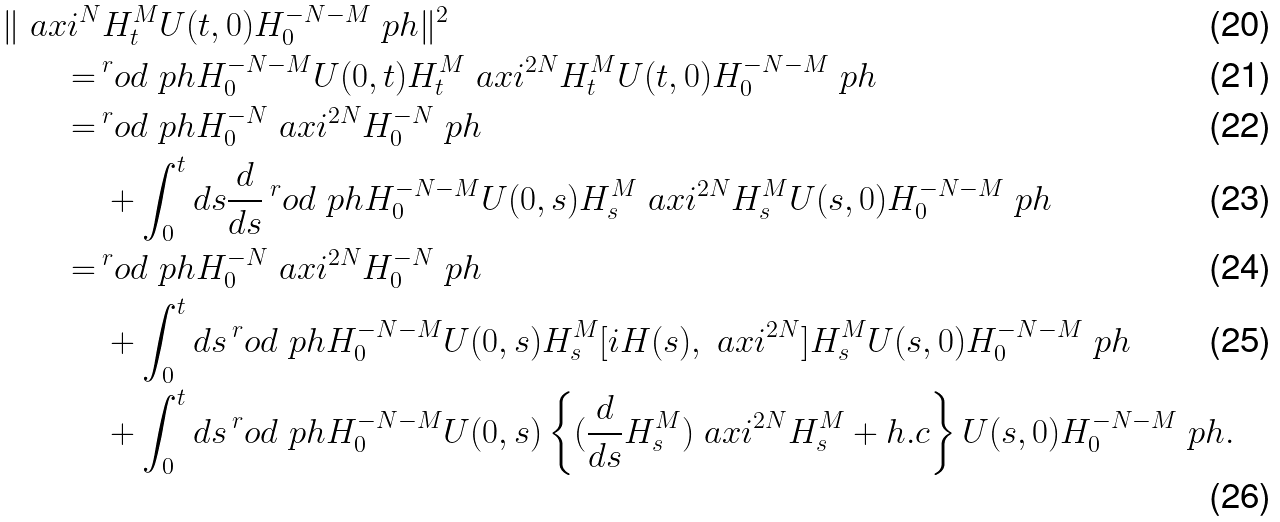Convert formula to latex. <formula><loc_0><loc_0><loc_500><loc_500>\| \ a x i ^ { N } & H _ { t } ^ { M } U ( t , 0 ) H _ { 0 } ^ { - N - M } \ p h \| ^ { 2 } \\ = \, & ^ { r } o d { \ p h } { H _ { 0 } ^ { - N - M } U ( 0 , t ) H _ { t } ^ { M } \ a x i ^ { 2 N } H _ { t } ^ { M } U ( t , 0 ) H _ { 0 } ^ { - N - M } \ p h } \\ = \, & ^ { r } o d { \ p h } { H _ { 0 } ^ { - N } \ a x i ^ { 2 N } H _ { 0 } ^ { - N } \ p h } \\ & + \int _ { 0 } ^ { t } d s \frac { d } { d s } \, ^ { r } o d { \ p h } { H _ { 0 } ^ { - N - M } U ( 0 , s ) H _ { s } ^ { M } \ a x i ^ { 2 N } H _ { s } ^ { M } U ( s , 0 ) H _ { 0 } ^ { - N - M } \ p h } \\ = \, & ^ { r } o d { \ p h } { H _ { 0 } ^ { - N } \ a x i ^ { 2 N } H _ { 0 } ^ { - N } \ p h } \\ & + \int _ { 0 } ^ { t } d s \, ^ { r } o d { \ p h } { H _ { 0 } ^ { - N - M } U ( 0 , s ) H _ { s } ^ { M } [ i H ( s ) , \ a x i ^ { 2 N } ] H _ { s } ^ { M } U ( s , 0 ) H _ { 0 } ^ { - N - M } \ p h } \\ & + \int _ { 0 } ^ { t } d s \, ^ { r } o d { \ p h } { H _ { 0 } ^ { - N - M } U ( 0 , s ) \left \{ ( \frac { d } { d s } H _ { s } ^ { M } ) \ a x i ^ { 2 N } H _ { s } ^ { M } + h . c \right \} U ( s , 0 ) H _ { 0 } ^ { - N - M } \ p h } .</formula> 